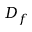<formula> <loc_0><loc_0><loc_500><loc_500>D _ { f }</formula> 